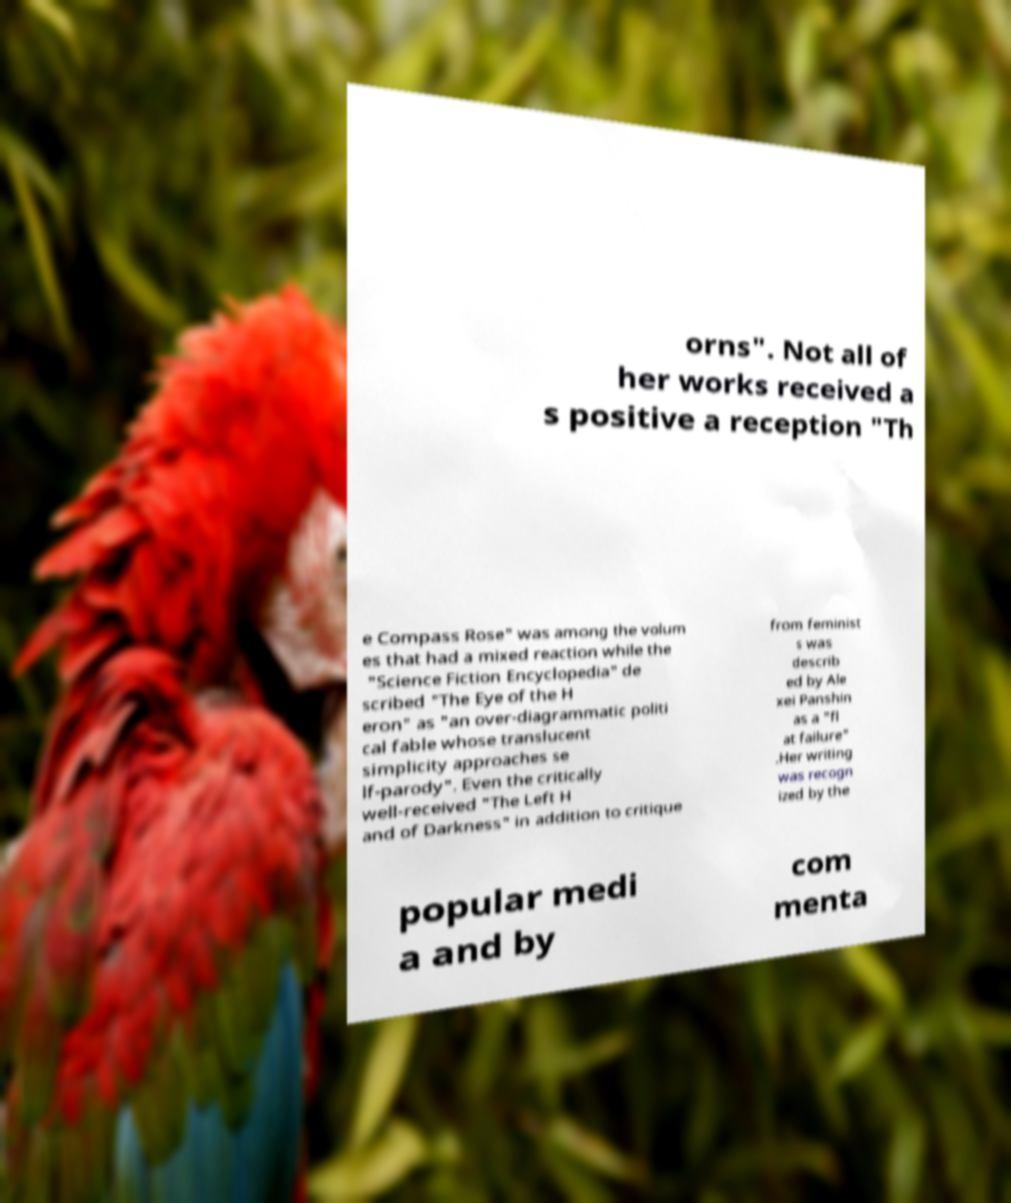Can you accurately transcribe the text from the provided image for me? orns". Not all of her works received a s positive a reception "Th e Compass Rose" was among the volum es that had a mixed reaction while the "Science Fiction Encyclopedia" de scribed "The Eye of the H eron" as "an over-diagrammatic politi cal fable whose translucent simplicity approaches se lf-parody". Even the critically well-received "The Left H and of Darkness" in addition to critique from feminist s was describ ed by Ale xei Panshin as a "fl at failure" .Her writing was recogn ized by the popular medi a and by com menta 